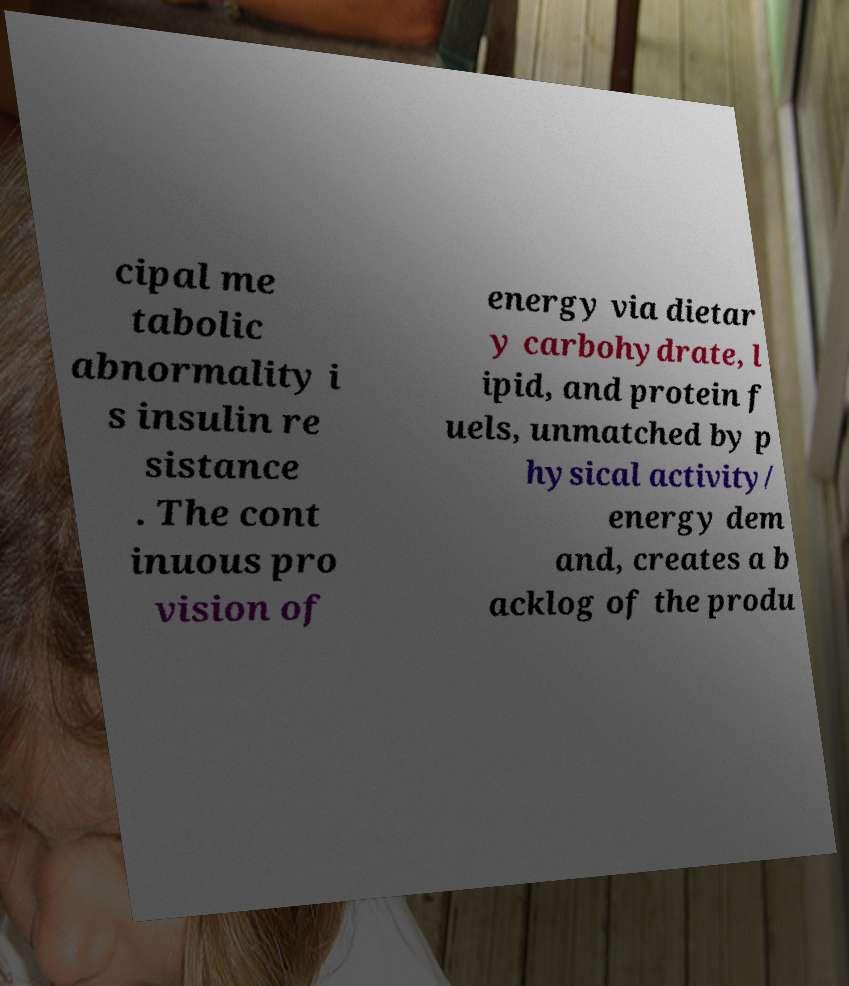There's text embedded in this image that I need extracted. Can you transcribe it verbatim? cipal me tabolic abnormality i s insulin re sistance . The cont inuous pro vision of energy via dietar y carbohydrate, l ipid, and protein f uels, unmatched by p hysical activity/ energy dem and, creates a b acklog of the produ 